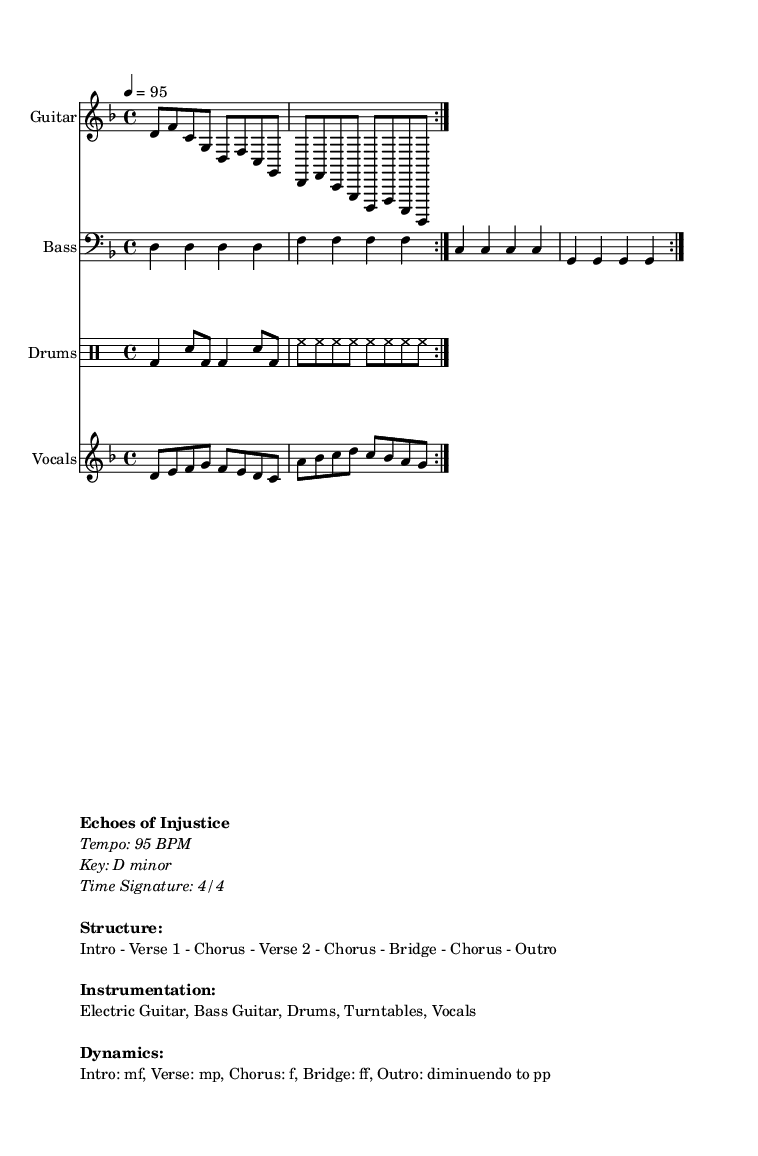What is the key signature of this music? The key signature indicates that the music is in D minor, which consists of one flat (B flat).
Answer: D minor What is the time signature of this piece? The time signature is given as 4/4, meaning there are four beats in a measure and the quarter note gets one beat.
Answer: 4/4 What is the tempo of the piece? The tempo marking states that the piece should be played at 95 BPM, indicating a moderate pace.
Answer: 95 BPM How many unique sections are there in the song structure? The structure includes eight sections: Intro, Verse 1, Chorus, Verse 2, Chorus, Bridge, Chorus, and Outro, totaling seven unique parts that repeat.
Answer: Seven What dynamics are indicated for the Intro section? The dynamics for the Intro are marked as mf, meaning mezzo-forte, which calls for a moderately loud performance.
Answer: mf What instruments are listed in the instrumentation? The instrumentation includes Electric Guitar, Bass Guitar, Drums, Turntables, and Vocals, which reflects a typical nu-metal setup with electronic elements.
Answer: Electric Guitar, Bass Guitar, Drums, Turntables, Vocals What form of expression do the lyrics likely address based on the title? Given the title "Echoes of Injustice," it suggests that the lyrics tackle themes of global inequality and cultural concerns, which aligns with socially conscious topics often found in nu-metal.
Answer: Global inequality and cultural appropriation 